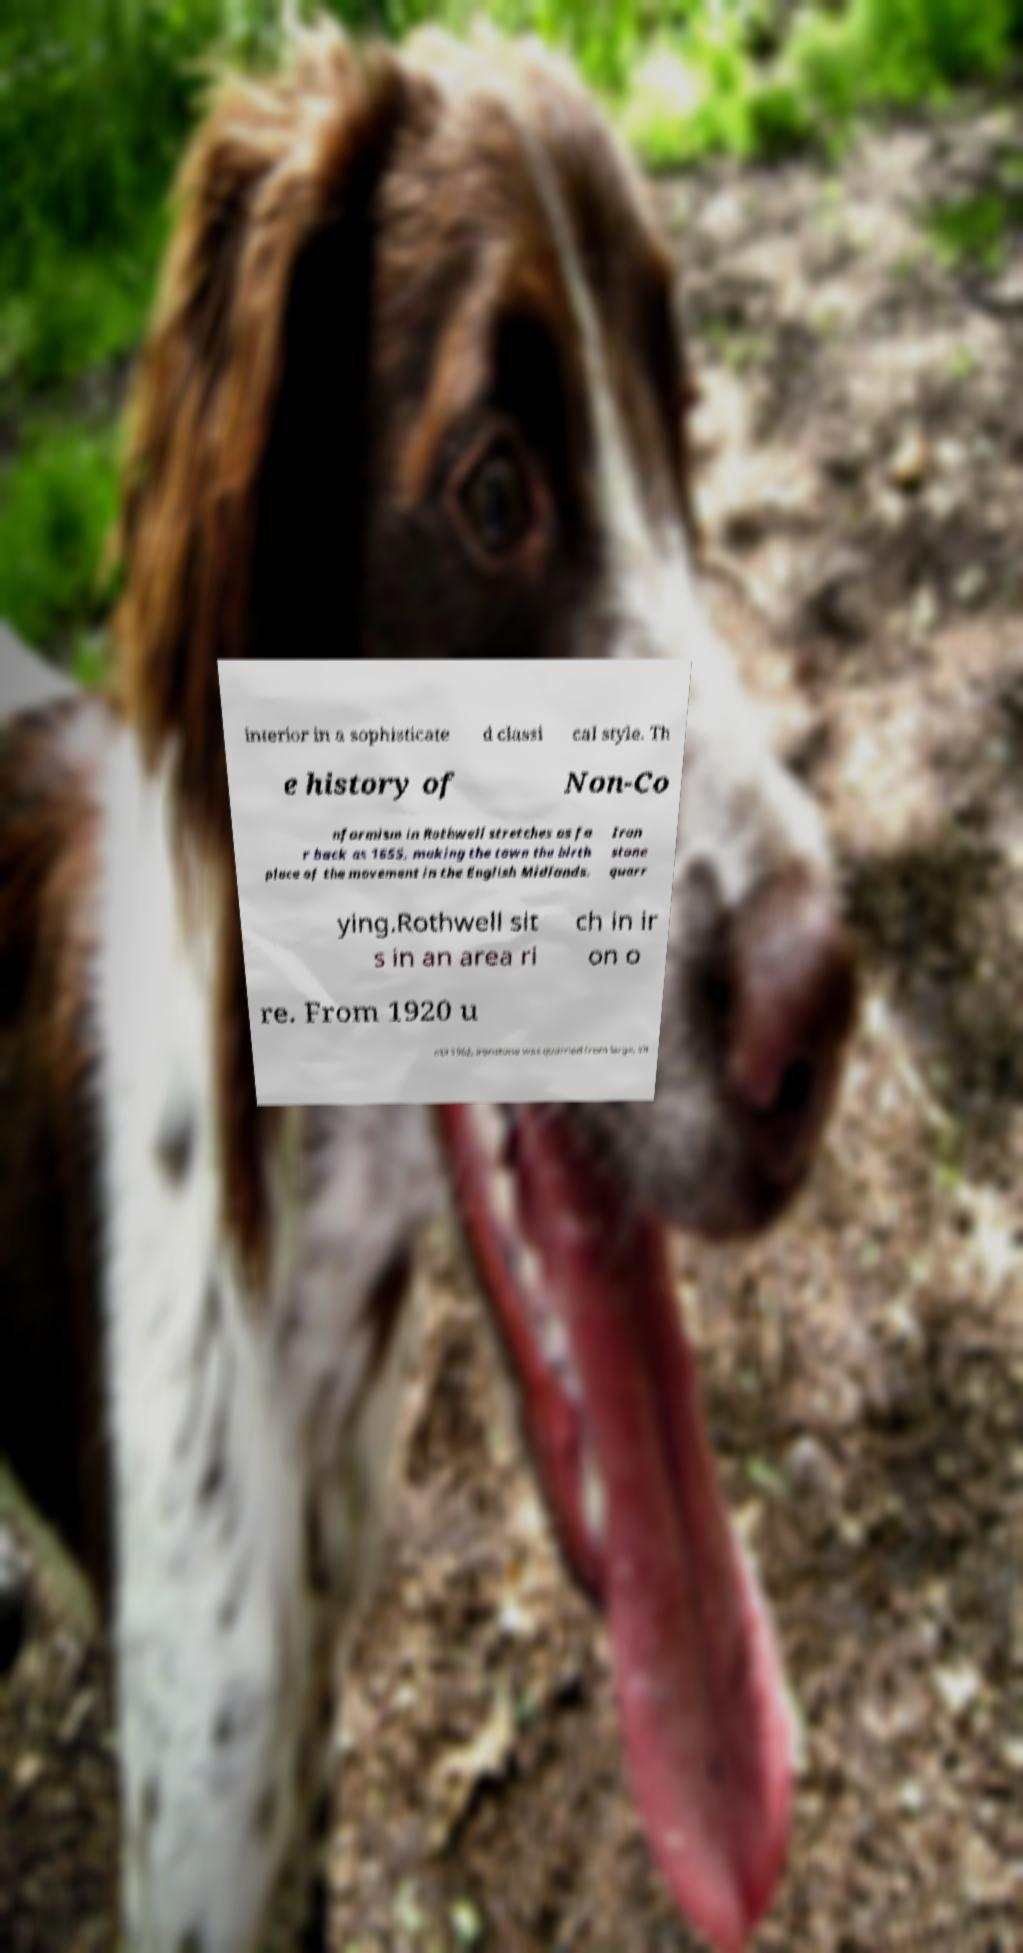For documentation purposes, I need the text within this image transcribed. Could you provide that? interior in a sophisticate d classi cal style. Th e history of Non-Co nformism in Rothwell stretches as fa r back as 1655, making the town the birth place of the movement in the English Midlands. Iron stone quarr ying.Rothwell sit s in an area ri ch in ir on o re. From 1920 u ntil 1962, ironstone was quarried from large, sh 